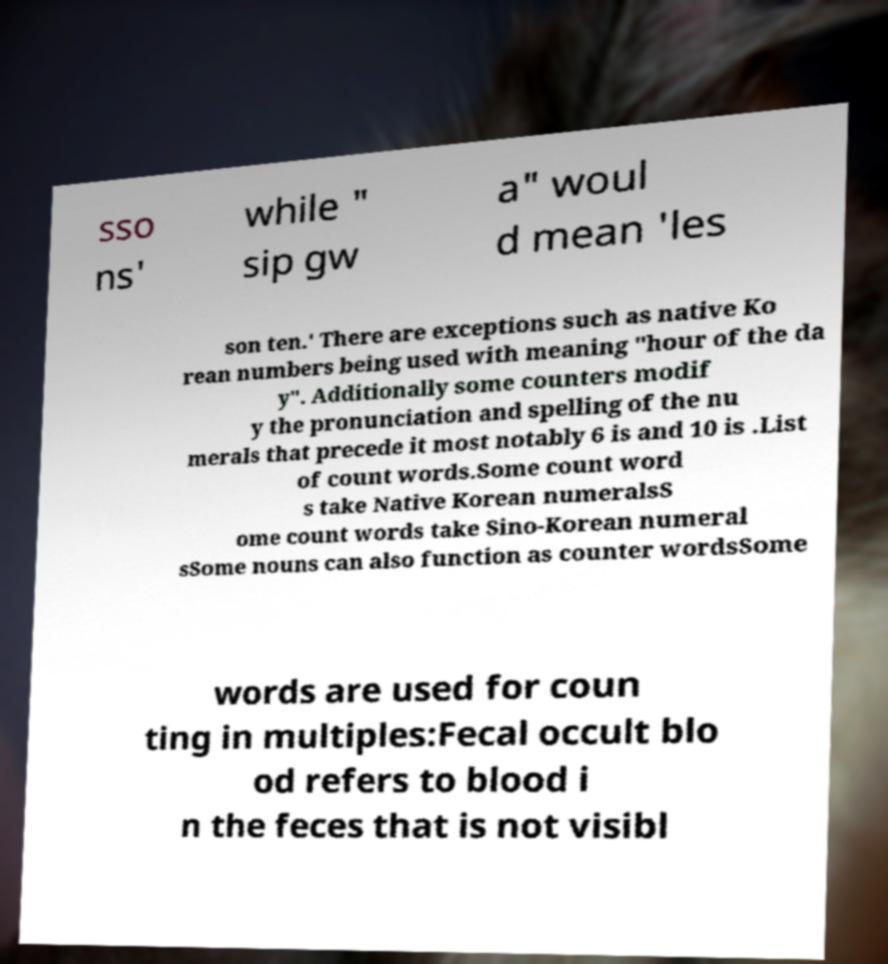Please read and relay the text visible in this image. What does it say? sso ns' while " sip gw a" woul d mean 'les son ten.' There are exceptions such as native Ko rean numbers being used with meaning "hour of the da y". Additionally some counters modif y the pronunciation and spelling of the nu merals that precede it most notably 6 is and 10 is .List of count words.Some count word s take Native Korean numeralsS ome count words take Sino-Korean numeral sSome nouns can also function as counter wordsSome words are used for coun ting in multiples:Fecal occult blo od refers to blood i n the feces that is not visibl 